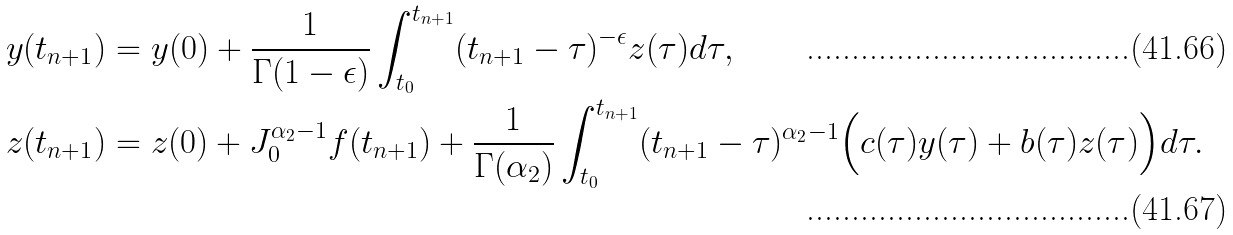Convert formula to latex. <formula><loc_0><loc_0><loc_500><loc_500>y ( t _ { n + 1 } ) & = y ( 0 ) + \frac { 1 } { \Gamma ( 1 - \epsilon ) } \int _ { t _ { 0 } } ^ { t _ { n + 1 } } ( t _ { n + 1 } - \tau ) ^ { - \epsilon } z ( \tau ) d \tau , \\ z ( t _ { n + 1 } ) & = z ( 0 ) + J _ { 0 } ^ { \alpha _ { 2 } - 1 } f ( t _ { n + 1 } ) + \frac { 1 } { \Gamma ( \alpha _ { 2 } ) } \int _ { t _ { 0 } } ^ { t _ { n + 1 } } ( t _ { n + 1 } - \tau ) ^ { \alpha _ { 2 } - 1 } \Big { ( } c ( \tau ) y ( \tau ) + b ( \tau ) z ( \tau ) \Big { ) } d \tau .</formula> 